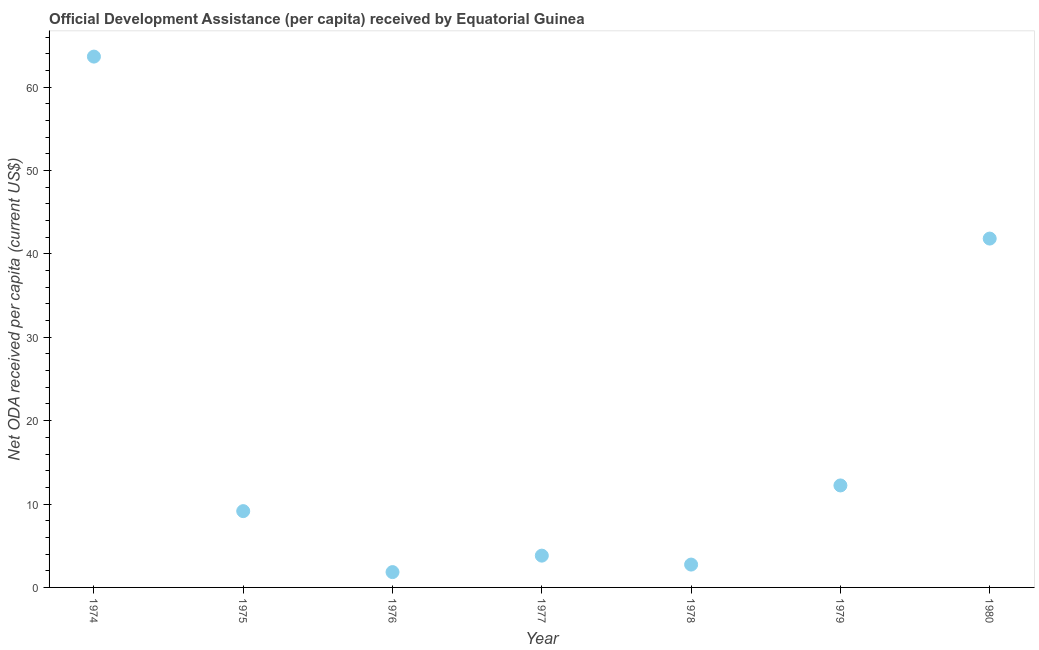What is the net oda received per capita in 1978?
Your answer should be compact. 2.74. Across all years, what is the maximum net oda received per capita?
Keep it short and to the point. 63.67. Across all years, what is the minimum net oda received per capita?
Your response must be concise. 1.84. In which year was the net oda received per capita maximum?
Offer a terse response. 1974. In which year was the net oda received per capita minimum?
Provide a succinct answer. 1976. What is the sum of the net oda received per capita?
Offer a terse response. 135.28. What is the difference between the net oda received per capita in 1979 and 1980?
Your answer should be compact. -29.61. What is the average net oda received per capita per year?
Your answer should be compact. 19.33. What is the median net oda received per capita?
Provide a succinct answer. 9.15. In how many years, is the net oda received per capita greater than 20 US$?
Offer a very short reply. 2. Do a majority of the years between 1978 and 1979 (inclusive) have net oda received per capita greater than 46 US$?
Make the answer very short. No. What is the ratio of the net oda received per capita in 1975 to that in 1980?
Make the answer very short. 0.22. Is the difference between the net oda received per capita in 1976 and 1979 greater than the difference between any two years?
Offer a terse response. No. What is the difference between the highest and the second highest net oda received per capita?
Ensure brevity in your answer.  21.83. Is the sum of the net oda received per capita in 1977 and 1979 greater than the maximum net oda received per capita across all years?
Your answer should be very brief. No. What is the difference between the highest and the lowest net oda received per capita?
Keep it short and to the point. 61.83. In how many years, is the net oda received per capita greater than the average net oda received per capita taken over all years?
Provide a short and direct response. 2. Does the net oda received per capita monotonically increase over the years?
Your answer should be very brief. No. How many dotlines are there?
Your answer should be very brief. 1. How many years are there in the graph?
Offer a terse response. 7. Does the graph contain grids?
Keep it short and to the point. No. What is the title of the graph?
Your answer should be very brief. Official Development Assistance (per capita) received by Equatorial Guinea. What is the label or title of the Y-axis?
Provide a short and direct response. Net ODA received per capita (current US$). What is the Net ODA received per capita (current US$) in 1974?
Give a very brief answer. 63.67. What is the Net ODA received per capita (current US$) in 1975?
Your answer should be very brief. 9.15. What is the Net ODA received per capita (current US$) in 1976?
Offer a terse response. 1.84. What is the Net ODA received per capita (current US$) in 1977?
Provide a succinct answer. 3.81. What is the Net ODA received per capita (current US$) in 1978?
Keep it short and to the point. 2.74. What is the Net ODA received per capita (current US$) in 1979?
Your answer should be compact. 12.23. What is the Net ODA received per capita (current US$) in 1980?
Keep it short and to the point. 41.84. What is the difference between the Net ODA received per capita (current US$) in 1974 and 1975?
Provide a succinct answer. 54.51. What is the difference between the Net ODA received per capita (current US$) in 1974 and 1976?
Provide a succinct answer. 61.83. What is the difference between the Net ODA received per capita (current US$) in 1974 and 1977?
Keep it short and to the point. 59.85. What is the difference between the Net ODA received per capita (current US$) in 1974 and 1978?
Provide a short and direct response. 60.92. What is the difference between the Net ODA received per capita (current US$) in 1974 and 1979?
Provide a short and direct response. 51.43. What is the difference between the Net ODA received per capita (current US$) in 1974 and 1980?
Make the answer very short. 21.83. What is the difference between the Net ODA received per capita (current US$) in 1975 and 1976?
Provide a succinct answer. 7.31. What is the difference between the Net ODA received per capita (current US$) in 1975 and 1977?
Offer a terse response. 5.34. What is the difference between the Net ODA received per capita (current US$) in 1975 and 1978?
Ensure brevity in your answer.  6.41. What is the difference between the Net ODA received per capita (current US$) in 1975 and 1979?
Keep it short and to the point. -3.08. What is the difference between the Net ODA received per capita (current US$) in 1975 and 1980?
Your answer should be compact. -32.69. What is the difference between the Net ODA received per capita (current US$) in 1976 and 1977?
Offer a terse response. -1.97. What is the difference between the Net ODA received per capita (current US$) in 1976 and 1978?
Your answer should be compact. -0.9. What is the difference between the Net ODA received per capita (current US$) in 1976 and 1979?
Your answer should be very brief. -10.39. What is the difference between the Net ODA received per capita (current US$) in 1976 and 1980?
Your response must be concise. -40. What is the difference between the Net ODA received per capita (current US$) in 1977 and 1978?
Your response must be concise. 1.07. What is the difference between the Net ODA received per capita (current US$) in 1977 and 1979?
Your answer should be compact. -8.42. What is the difference between the Net ODA received per capita (current US$) in 1977 and 1980?
Offer a terse response. -38.03. What is the difference between the Net ODA received per capita (current US$) in 1978 and 1979?
Your answer should be compact. -9.49. What is the difference between the Net ODA received per capita (current US$) in 1978 and 1980?
Make the answer very short. -39.1. What is the difference between the Net ODA received per capita (current US$) in 1979 and 1980?
Offer a very short reply. -29.61. What is the ratio of the Net ODA received per capita (current US$) in 1974 to that in 1975?
Ensure brevity in your answer.  6.96. What is the ratio of the Net ODA received per capita (current US$) in 1974 to that in 1976?
Your answer should be very brief. 34.64. What is the ratio of the Net ODA received per capita (current US$) in 1974 to that in 1977?
Your answer should be compact. 16.7. What is the ratio of the Net ODA received per capita (current US$) in 1974 to that in 1978?
Give a very brief answer. 23.23. What is the ratio of the Net ODA received per capita (current US$) in 1974 to that in 1979?
Give a very brief answer. 5.21. What is the ratio of the Net ODA received per capita (current US$) in 1974 to that in 1980?
Ensure brevity in your answer.  1.52. What is the ratio of the Net ODA received per capita (current US$) in 1975 to that in 1976?
Offer a very short reply. 4.98. What is the ratio of the Net ODA received per capita (current US$) in 1975 to that in 1977?
Offer a very short reply. 2.4. What is the ratio of the Net ODA received per capita (current US$) in 1975 to that in 1978?
Your answer should be very brief. 3.34. What is the ratio of the Net ODA received per capita (current US$) in 1975 to that in 1979?
Make the answer very short. 0.75. What is the ratio of the Net ODA received per capita (current US$) in 1975 to that in 1980?
Your response must be concise. 0.22. What is the ratio of the Net ODA received per capita (current US$) in 1976 to that in 1977?
Offer a very short reply. 0.48. What is the ratio of the Net ODA received per capita (current US$) in 1976 to that in 1978?
Provide a succinct answer. 0.67. What is the ratio of the Net ODA received per capita (current US$) in 1976 to that in 1979?
Your response must be concise. 0.15. What is the ratio of the Net ODA received per capita (current US$) in 1976 to that in 1980?
Provide a short and direct response. 0.04. What is the ratio of the Net ODA received per capita (current US$) in 1977 to that in 1978?
Keep it short and to the point. 1.39. What is the ratio of the Net ODA received per capita (current US$) in 1977 to that in 1979?
Your response must be concise. 0.31. What is the ratio of the Net ODA received per capita (current US$) in 1977 to that in 1980?
Offer a very short reply. 0.09. What is the ratio of the Net ODA received per capita (current US$) in 1978 to that in 1979?
Give a very brief answer. 0.22. What is the ratio of the Net ODA received per capita (current US$) in 1978 to that in 1980?
Make the answer very short. 0.07. What is the ratio of the Net ODA received per capita (current US$) in 1979 to that in 1980?
Give a very brief answer. 0.29. 